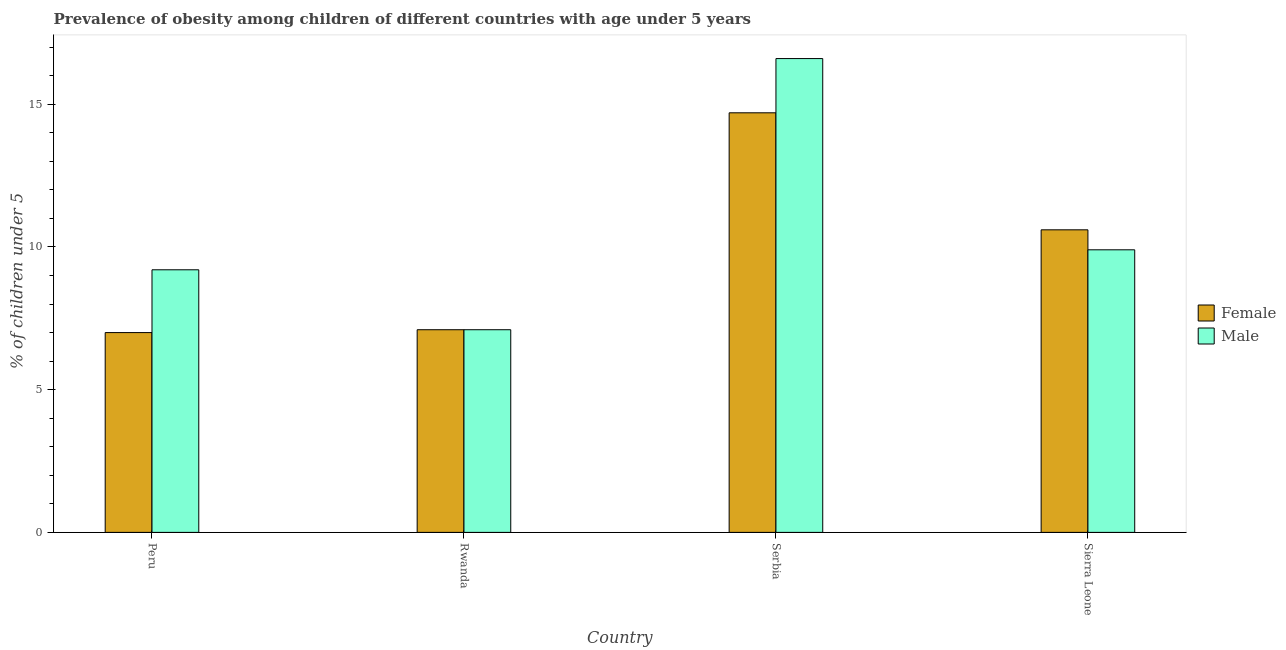How many groups of bars are there?
Make the answer very short. 4. Are the number of bars per tick equal to the number of legend labels?
Your answer should be very brief. Yes. Are the number of bars on each tick of the X-axis equal?
Keep it short and to the point. Yes. How many bars are there on the 1st tick from the left?
Keep it short and to the point. 2. What is the label of the 3rd group of bars from the left?
Offer a very short reply. Serbia. What is the percentage of obese male children in Serbia?
Your answer should be very brief. 16.6. Across all countries, what is the maximum percentage of obese female children?
Make the answer very short. 14.7. In which country was the percentage of obese male children maximum?
Your response must be concise. Serbia. What is the total percentage of obese male children in the graph?
Provide a short and direct response. 42.8. What is the difference between the percentage of obese male children in Rwanda and that in Sierra Leone?
Make the answer very short. -2.8. What is the difference between the percentage of obese male children in Sierra Leone and the percentage of obese female children in Rwanda?
Provide a succinct answer. 2.8. What is the average percentage of obese female children per country?
Offer a very short reply. 9.85. What is the difference between the percentage of obese female children and percentage of obese male children in Peru?
Your response must be concise. -2.2. What is the ratio of the percentage of obese female children in Serbia to that in Sierra Leone?
Ensure brevity in your answer.  1.39. What is the difference between the highest and the second highest percentage of obese male children?
Offer a very short reply. 6.7. What is the difference between the highest and the lowest percentage of obese female children?
Give a very brief answer. 7.7. In how many countries, is the percentage of obese male children greater than the average percentage of obese male children taken over all countries?
Provide a short and direct response. 1. Is the sum of the percentage of obese male children in Serbia and Sierra Leone greater than the maximum percentage of obese female children across all countries?
Your response must be concise. Yes. What does the 2nd bar from the right in Rwanda represents?
Keep it short and to the point. Female. How many countries are there in the graph?
Give a very brief answer. 4. What is the difference between two consecutive major ticks on the Y-axis?
Offer a very short reply. 5. Where does the legend appear in the graph?
Your answer should be very brief. Center right. How many legend labels are there?
Provide a short and direct response. 2. What is the title of the graph?
Your answer should be very brief. Prevalence of obesity among children of different countries with age under 5 years. What is the label or title of the X-axis?
Keep it short and to the point. Country. What is the label or title of the Y-axis?
Your response must be concise.  % of children under 5. What is the  % of children under 5 of Male in Peru?
Provide a short and direct response. 9.2. What is the  % of children under 5 of Female in Rwanda?
Make the answer very short. 7.1. What is the  % of children under 5 in Male in Rwanda?
Keep it short and to the point. 7.1. What is the  % of children under 5 in Female in Serbia?
Offer a very short reply. 14.7. What is the  % of children under 5 of Male in Serbia?
Ensure brevity in your answer.  16.6. What is the  % of children under 5 of Female in Sierra Leone?
Offer a terse response. 10.6. What is the  % of children under 5 of Male in Sierra Leone?
Provide a short and direct response. 9.9. Across all countries, what is the maximum  % of children under 5 in Female?
Keep it short and to the point. 14.7. Across all countries, what is the maximum  % of children under 5 of Male?
Offer a terse response. 16.6. Across all countries, what is the minimum  % of children under 5 in Male?
Offer a terse response. 7.1. What is the total  % of children under 5 of Female in the graph?
Provide a short and direct response. 39.4. What is the total  % of children under 5 in Male in the graph?
Keep it short and to the point. 42.8. What is the difference between the  % of children under 5 of Male in Peru and that in Rwanda?
Provide a succinct answer. 2.1. What is the difference between the  % of children under 5 in Male in Peru and that in Serbia?
Offer a terse response. -7.4. What is the difference between the  % of children under 5 of Female in Peru and that in Sierra Leone?
Your answer should be very brief. -3.6. What is the difference between the  % of children under 5 of Male in Peru and that in Sierra Leone?
Keep it short and to the point. -0.7. What is the difference between the  % of children under 5 of Female in Rwanda and that in Serbia?
Give a very brief answer. -7.6. What is the difference between the  % of children under 5 of Female in Rwanda and that in Sierra Leone?
Your answer should be very brief. -3.5. What is the difference between the  % of children under 5 in Male in Rwanda and that in Sierra Leone?
Your answer should be very brief. -2.8. What is the difference between the  % of children under 5 in Male in Serbia and that in Sierra Leone?
Offer a very short reply. 6.7. What is the difference between the  % of children under 5 of Female in Peru and the  % of children under 5 of Male in Serbia?
Give a very brief answer. -9.6. What is the difference between the  % of children under 5 of Female in Peru and the  % of children under 5 of Male in Sierra Leone?
Give a very brief answer. -2.9. What is the difference between the  % of children under 5 in Female in Rwanda and the  % of children under 5 in Male in Serbia?
Make the answer very short. -9.5. What is the difference between the  % of children under 5 in Female in Rwanda and the  % of children under 5 in Male in Sierra Leone?
Your response must be concise. -2.8. What is the average  % of children under 5 in Female per country?
Give a very brief answer. 9.85. What is the average  % of children under 5 in Male per country?
Give a very brief answer. 10.7. What is the difference between the  % of children under 5 in Female and  % of children under 5 in Male in Peru?
Provide a short and direct response. -2.2. What is the difference between the  % of children under 5 of Female and  % of children under 5 of Male in Serbia?
Keep it short and to the point. -1.9. What is the difference between the  % of children under 5 of Female and  % of children under 5 of Male in Sierra Leone?
Offer a terse response. 0.7. What is the ratio of the  % of children under 5 of Female in Peru to that in Rwanda?
Your answer should be compact. 0.99. What is the ratio of the  % of children under 5 in Male in Peru to that in Rwanda?
Keep it short and to the point. 1.3. What is the ratio of the  % of children under 5 in Female in Peru to that in Serbia?
Offer a very short reply. 0.48. What is the ratio of the  % of children under 5 of Male in Peru to that in Serbia?
Provide a short and direct response. 0.55. What is the ratio of the  % of children under 5 of Female in Peru to that in Sierra Leone?
Keep it short and to the point. 0.66. What is the ratio of the  % of children under 5 of Male in Peru to that in Sierra Leone?
Offer a terse response. 0.93. What is the ratio of the  % of children under 5 of Female in Rwanda to that in Serbia?
Your response must be concise. 0.48. What is the ratio of the  % of children under 5 of Male in Rwanda to that in Serbia?
Keep it short and to the point. 0.43. What is the ratio of the  % of children under 5 of Female in Rwanda to that in Sierra Leone?
Keep it short and to the point. 0.67. What is the ratio of the  % of children under 5 in Male in Rwanda to that in Sierra Leone?
Keep it short and to the point. 0.72. What is the ratio of the  % of children under 5 in Female in Serbia to that in Sierra Leone?
Ensure brevity in your answer.  1.39. What is the ratio of the  % of children under 5 of Male in Serbia to that in Sierra Leone?
Give a very brief answer. 1.68. What is the difference between the highest and the lowest  % of children under 5 of Female?
Keep it short and to the point. 7.7. What is the difference between the highest and the lowest  % of children under 5 of Male?
Keep it short and to the point. 9.5. 